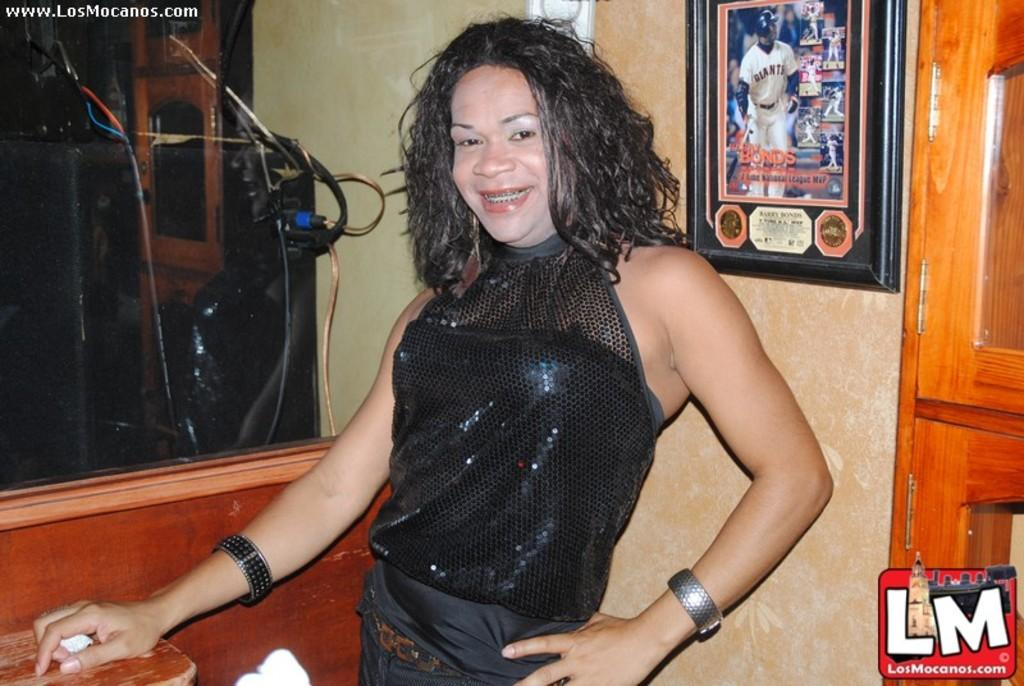Who is the main subject in the image? There is a woman in the image. What is the woman wearing? The woman is wearing a black dress. What is the woman doing in the image? The woman is posing for the camera. What can be seen in the background of the image? There is a glass element and a wooden door visible in the background. What type of harmony is being achieved between the woman and the glass element in the image? There is no indication of harmony or any interaction between the woman and the glass element in the image. 